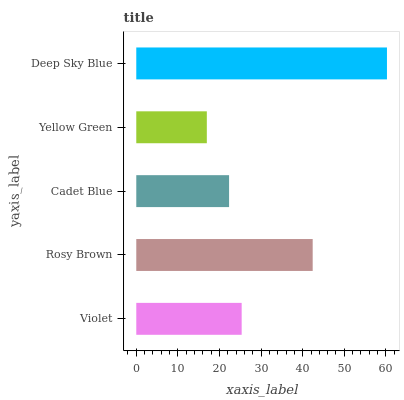Is Yellow Green the minimum?
Answer yes or no. Yes. Is Deep Sky Blue the maximum?
Answer yes or no. Yes. Is Rosy Brown the minimum?
Answer yes or no. No. Is Rosy Brown the maximum?
Answer yes or no. No. Is Rosy Brown greater than Violet?
Answer yes or no. Yes. Is Violet less than Rosy Brown?
Answer yes or no. Yes. Is Violet greater than Rosy Brown?
Answer yes or no. No. Is Rosy Brown less than Violet?
Answer yes or no. No. Is Violet the high median?
Answer yes or no. Yes. Is Violet the low median?
Answer yes or no. Yes. Is Deep Sky Blue the high median?
Answer yes or no. No. Is Deep Sky Blue the low median?
Answer yes or no. No. 